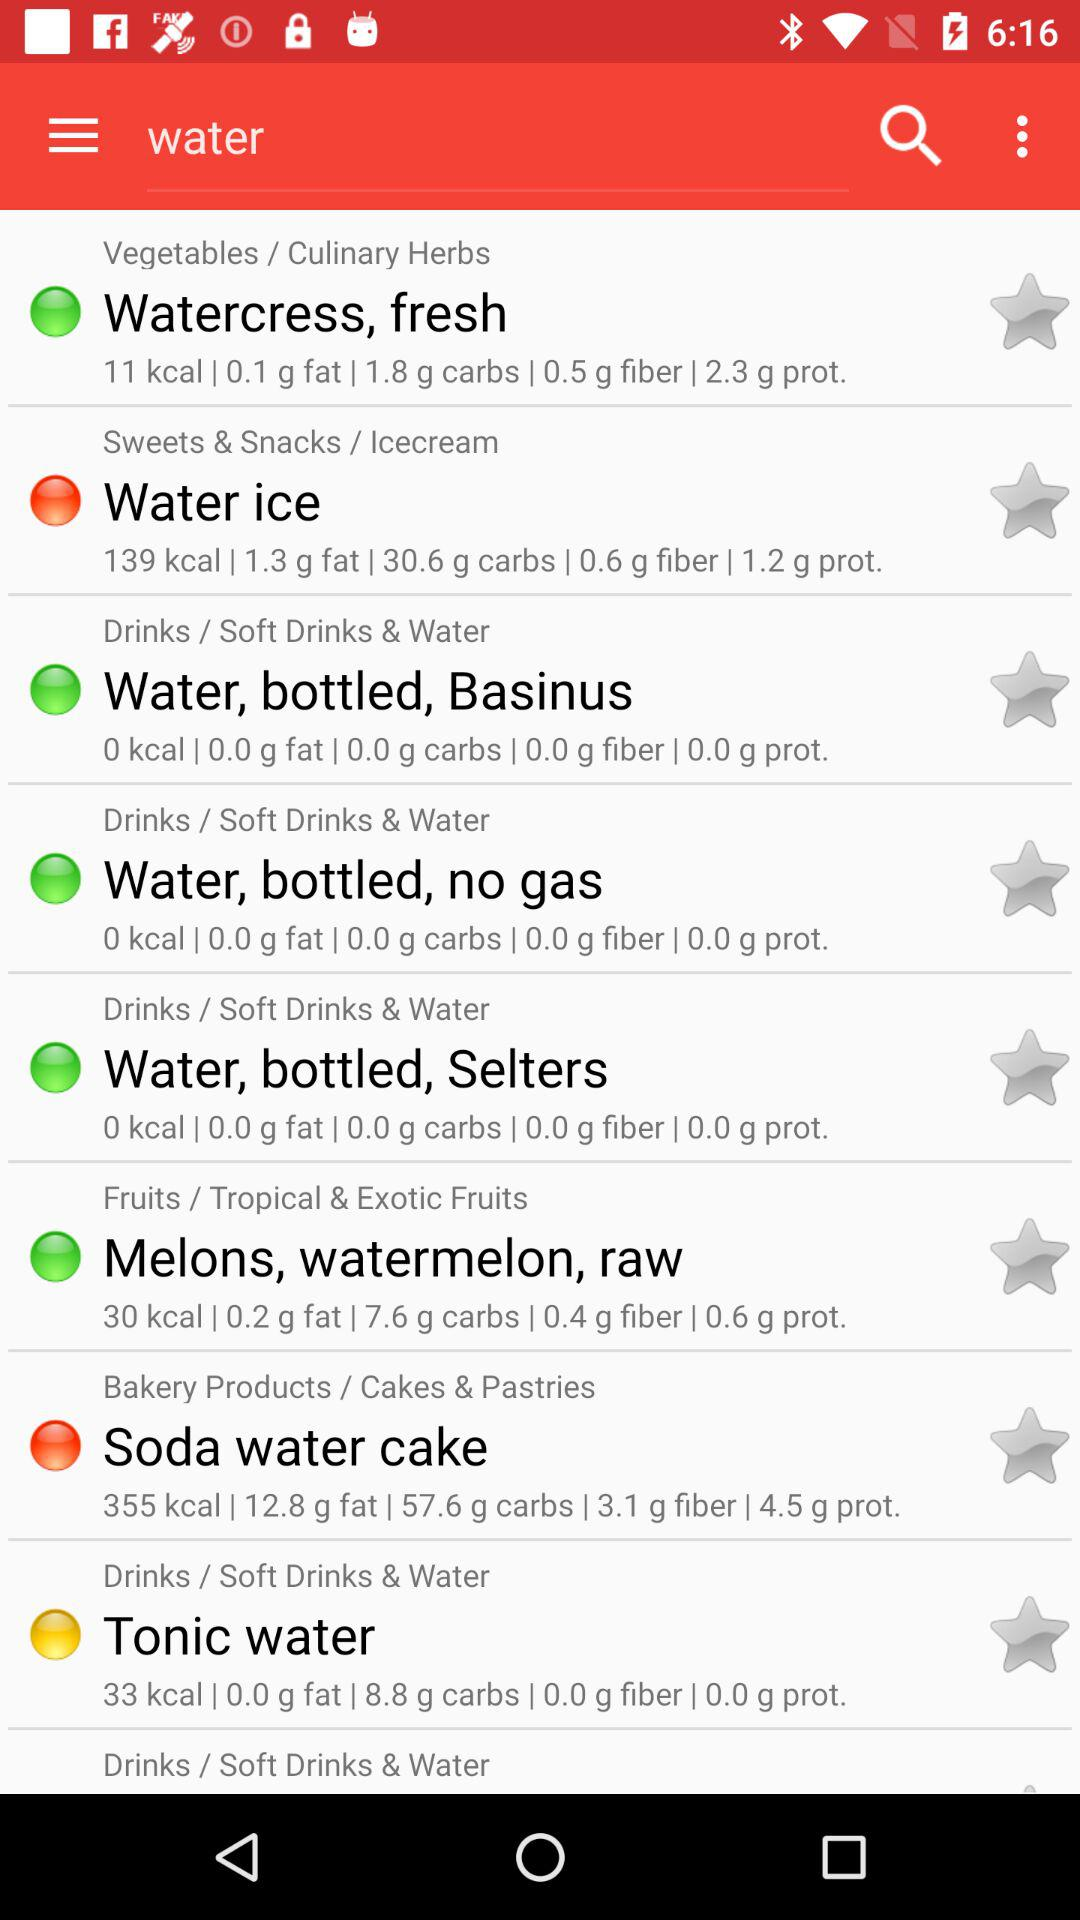How many calories are in "Soda water cake"? There are 355 calories in "Soda water cake". 